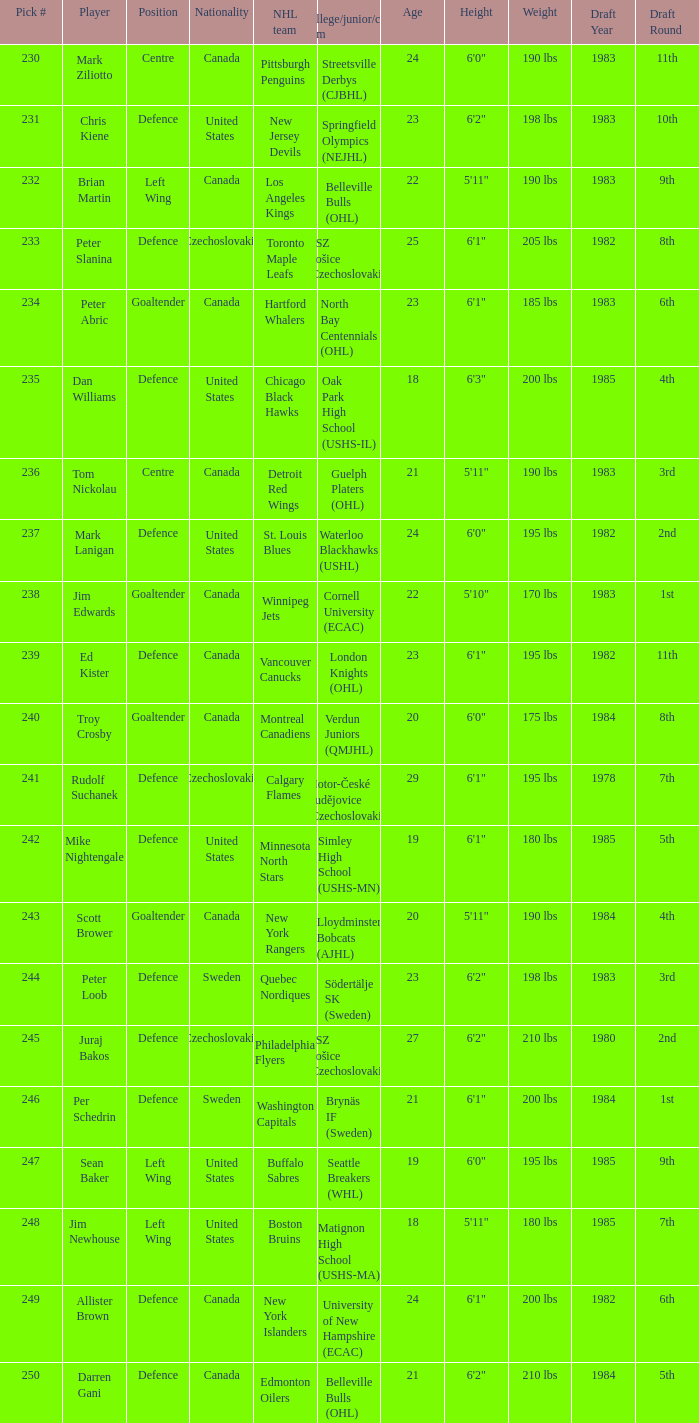List the players for team brynäs if (sweden). Per Schedrin. 